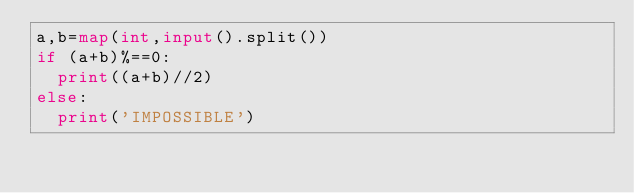<code> <loc_0><loc_0><loc_500><loc_500><_Python_>a,b=map(int,input().split())
if (a+b)%==0:
  print((a+b)//2)
else:
  print('IMPOSSIBLE')</code> 